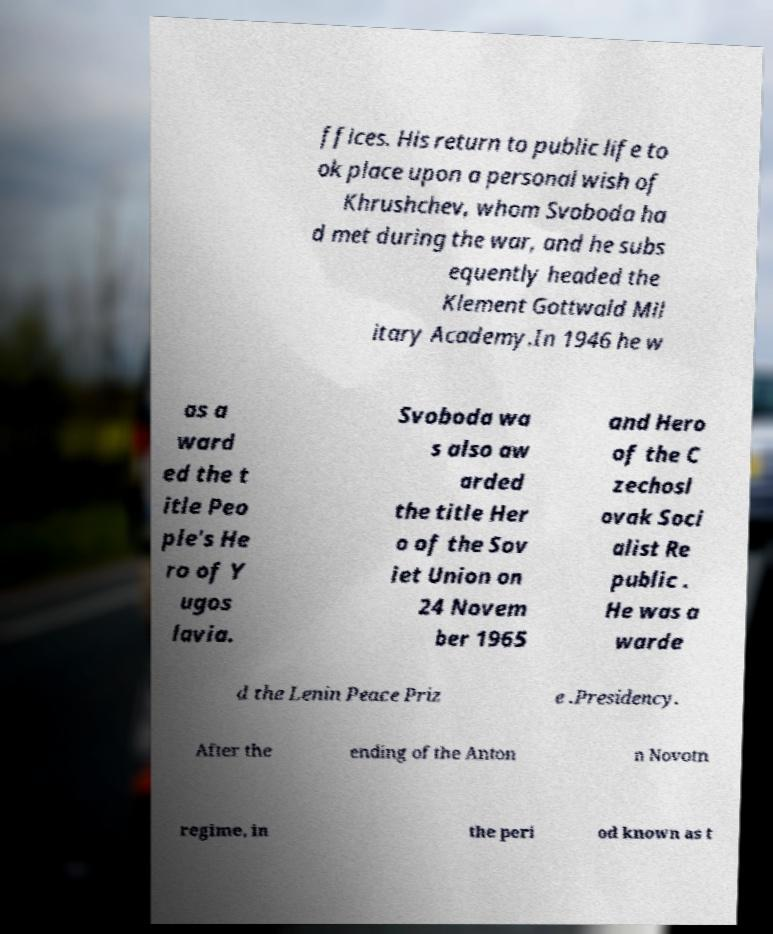Can you read and provide the text displayed in the image?This photo seems to have some interesting text. Can you extract and type it out for me? ffices. His return to public life to ok place upon a personal wish of Khrushchev, whom Svoboda ha d met during the war, and he subs equently headed the Klement Gottwald Mil itary Academy.In 1946 he w as a ward ed the t itle Peo ple's He ro of Y ugos lavia. Svoboda wa s also aw arded the title Her o of the Sov iet Union on 24 Novem ber 1965 and Hero of the C zechosl ovak Soci alist Re public . He was a warde d the Lenin Peace Priz e .Presidency. After the ending of the Anton n Novotn regime, in the peri od known as t 